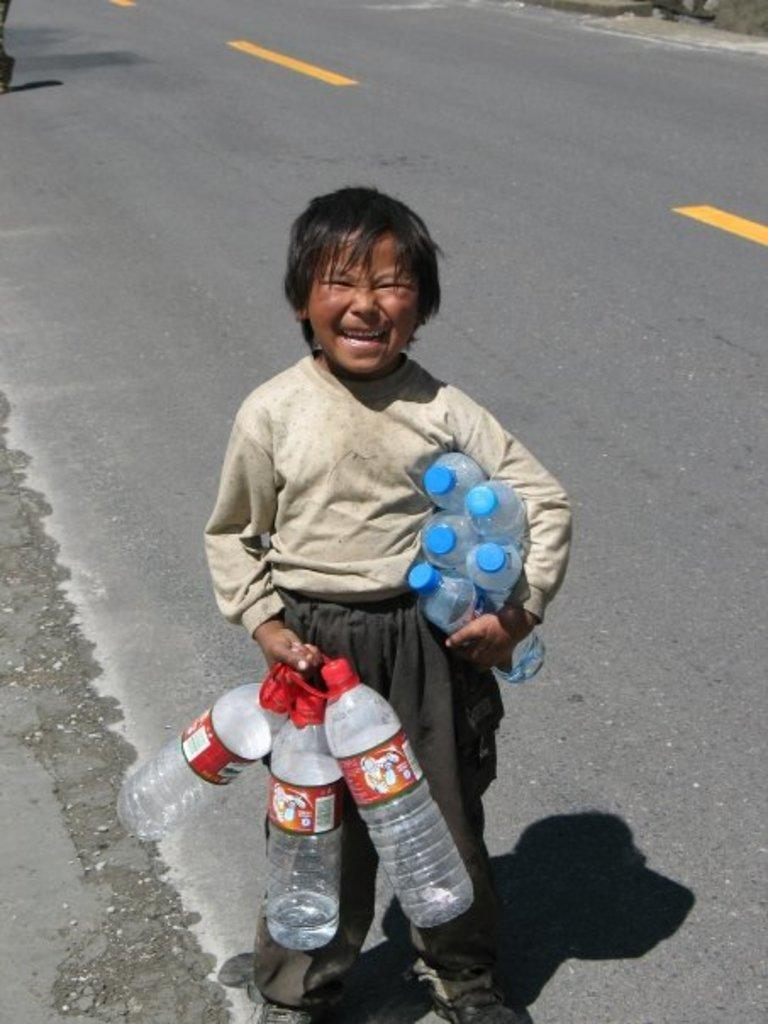What is the boy doing in the image? The boy is standing on the road in the image. What can be seen to the right of the boy? The boy has a red bottle to his right. What can be seen to the left of the boy? The boy has four blue bottles to his left. What is the color of the divider on the road? There is a yellow color divider on the road. What type of story is the boy telling to the judge in the image? There is no judge or story present in the image; it only shows a boy standing on the road with bottles and a yellow color divider. 